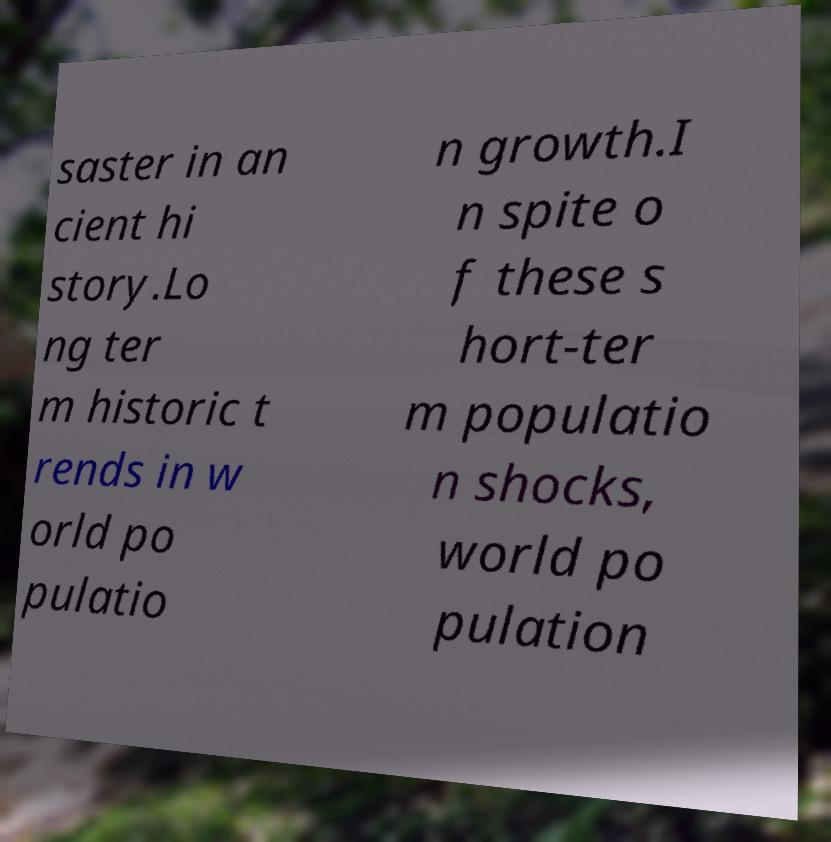Can you read and provide the text displayed in the image?This photo seems to have some interesting text. Can you extract and type it out for me? saster in an cient hi story.Lo ng ter m historic t rends in w orld po pulatio n growth.I n spite o f these s hort-ter m populatio n shocks, world po pulation 